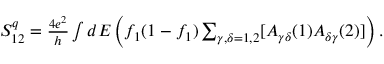Convert formula to latex. <formula><loc_0><loc_0><loc_500><loc_500>\begin{array} { r } { S _ { 1 2 } ^ { q } = \frac { 4 e ^ { 2 } } { h } \int d E \left ( f _ { 1 } ( 1 - f _ { 1 } ) \sum _ { \gamma , \delta = 1 , 2 } [ A _ { \gamma \delta } ( 1 ) A _ { \delta \gamma } ( 2 ) ] \right ) . } \end{array}</formula> 